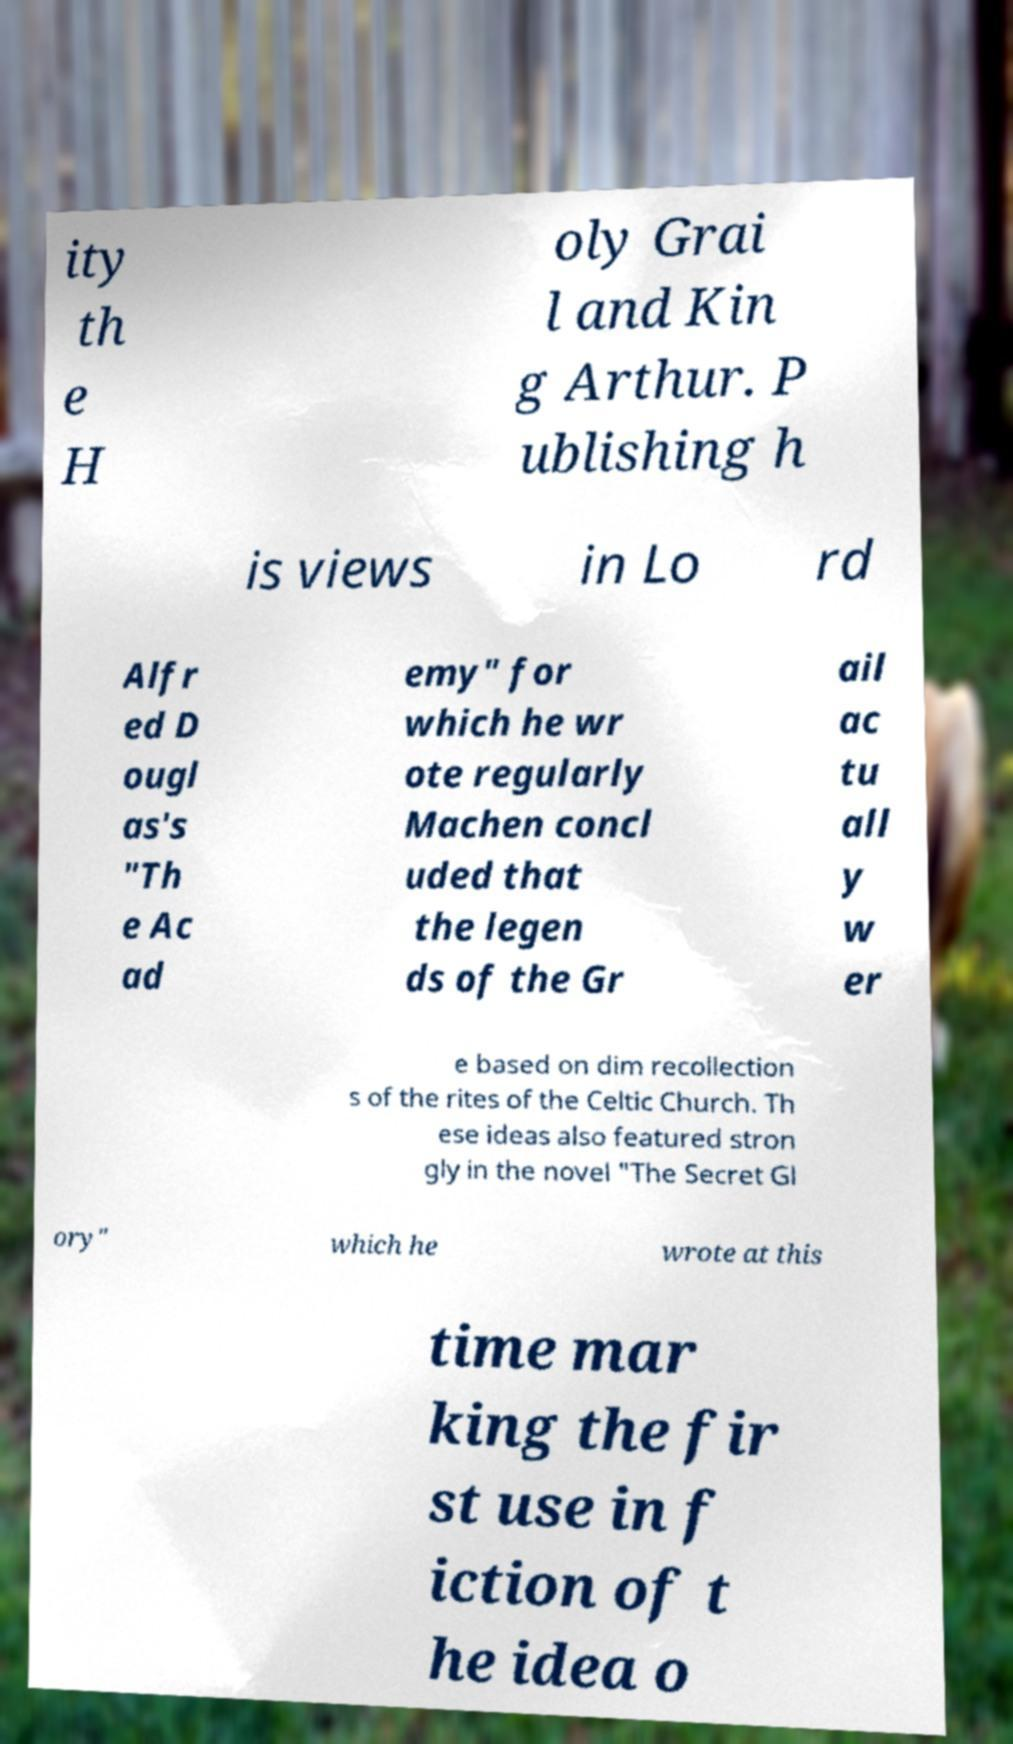There's text embedded in this image that I need extracted. Can you transcribe it verbatim? ity th e H oly Grai l and Kin g Arthur. P ublishing h is views in Lo rd Alfr ed D ougl as's "Th e Ac ad emy" for which he wr ote regularly Machen concl uded that the legen ds of the Gr ail ac tu all y w er e based on dim recollection s of the rites of the Celtic Church. Th ese ideas also featured stron gly in the novel "The Secret Gl ory" which he wrote at this time mar king the fir st use in f iction of t he idea o 